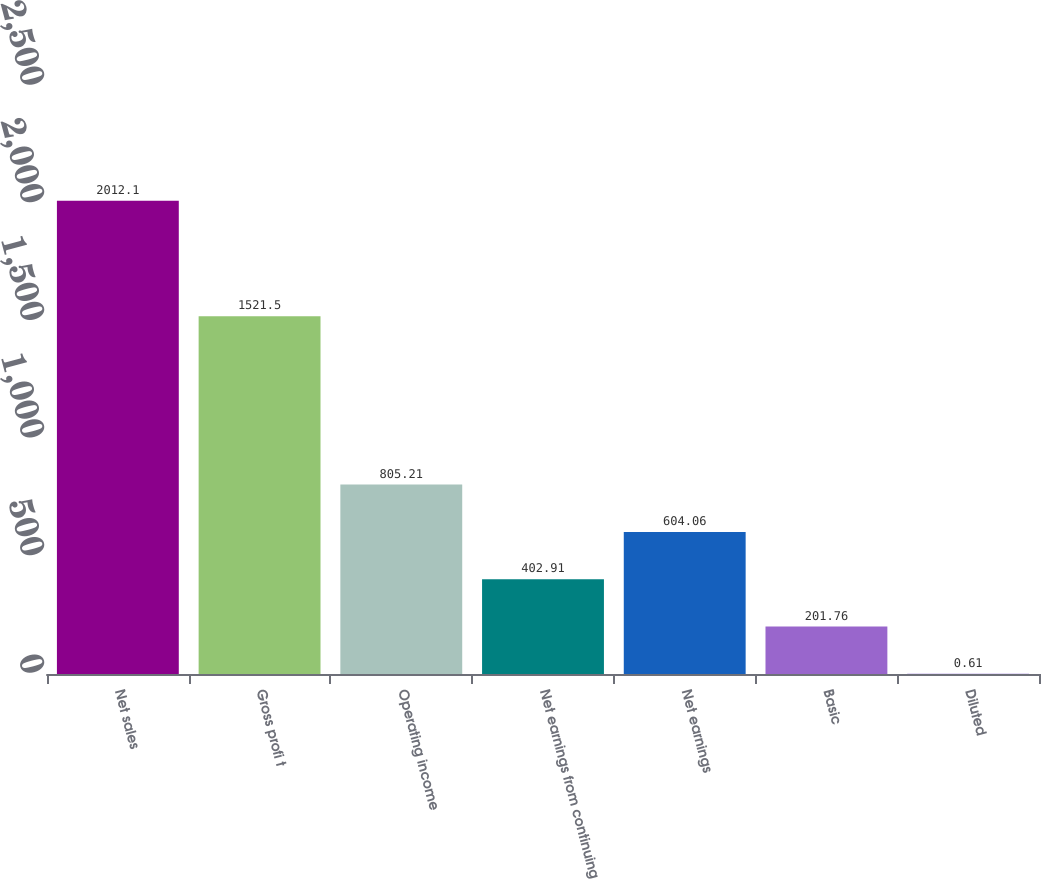<chart> <loc_0><loc_0><loc_500><loc_500><bar_chart><fcel>Net sales<fcel>Gross profi t<fcel>Operating income<fcel>Net earnings from continuing<fcel>Net earnings<fcel>Basic<fcel>Diluted<nl><fcel>2012.1<fcel>1521.5<fcel>805.21<fcel>402.91<fcel>604.06<fcel>201.76<fcel>0.61<nl></chart> 